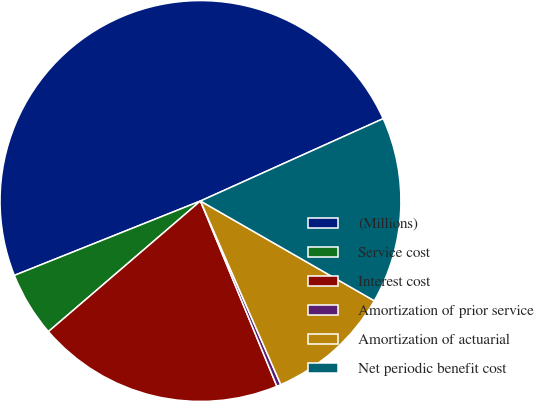Convert chart. <chart><loc_0><loc_0><loc_500><loc_500><pie_chart><fcel>(Millions)<fcel>Service cost<fcel>Interest cost<fcel>Amortization of prior service<fcel>Amortization of actuarial<fcel>Net periodic benefit cost<nl><fcel>49.31%<fcel>5.24%<fcel>19.93%<fcel>0.34%<fcel>10.14%<fcel>15.03%<nl></chart> 